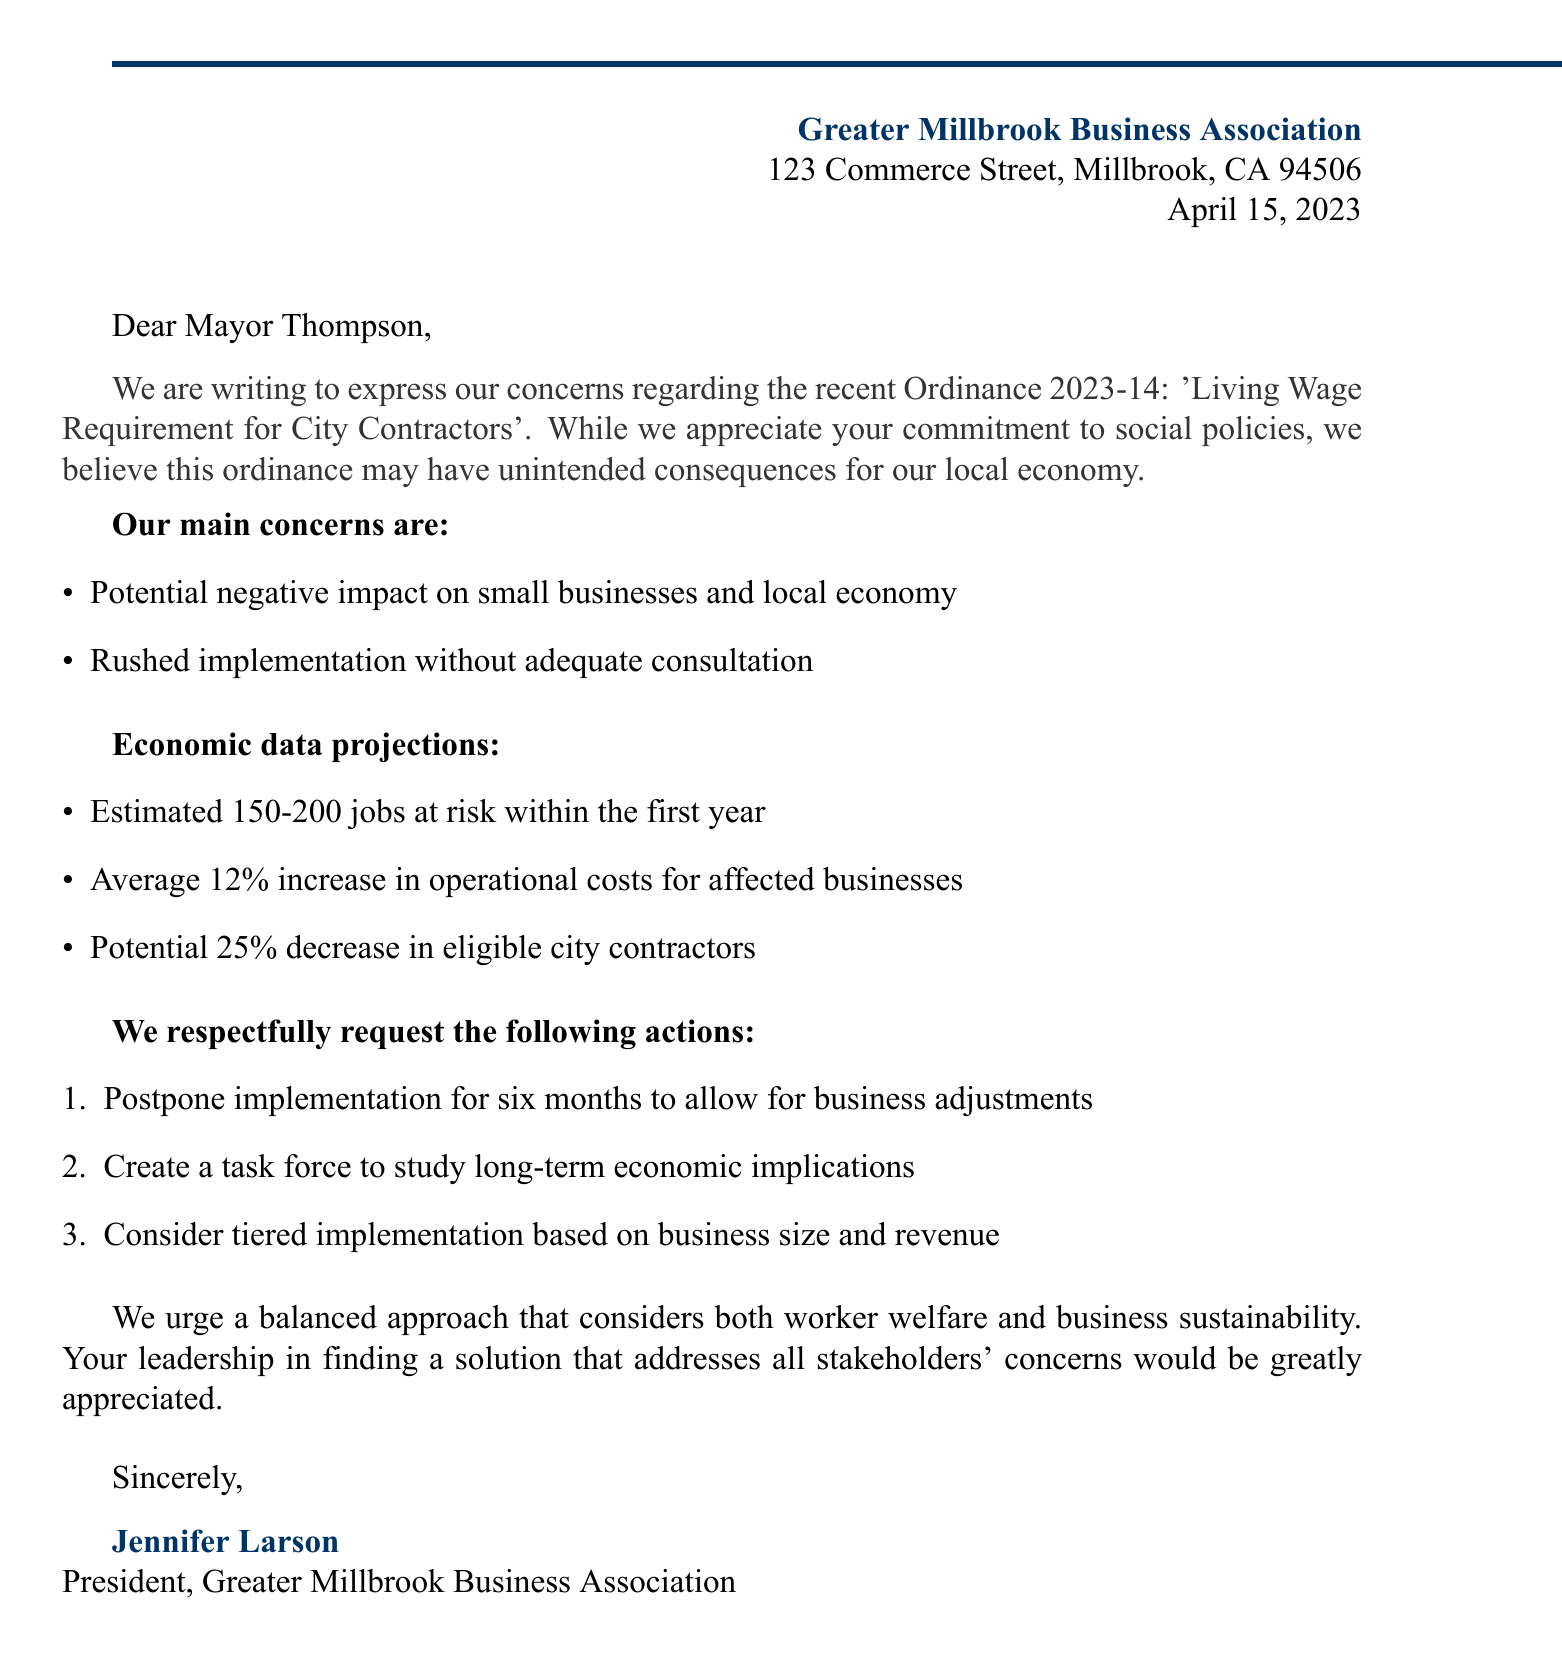What is the sender's name? The sender's name is mentioned at the beginning of the document, which is the Greater Millbrook Business Association.
Answer: Greater Millbrook Business Association What is the date of the letter? The date appears in the letter header and is specified as April 15, 2023.
Answer: April 15, 2023 What ordinance is being referred to? The ordinance being discussed is named in the document, specifically Ordinance 2023-14.
Answer: Ordinance 2023-14 How many jobs are estimated to be at risk? The letter states an estimate of jobs at risk, which is between 150 and 200 jobs.
Answer: 150-200 jobs What percentage increase in operational costs is projected? The economic data in the letter mentions an average increase of 12% in operational costs for affected businesses.
Answer: 12% What is one requested action from the business association? The letter lists specific requested actions; one is to postpone implementation for six months.
Answer: Postpone implementation for six months Who signed the letter? The closing signature of the letter indicates who signed it, which is Jennifer Larson.
Answer: Jennifer Larson What is Jennifer Larson's title? The title is provided at the end of the letter, stating she is the President of the association.
Answer: President 